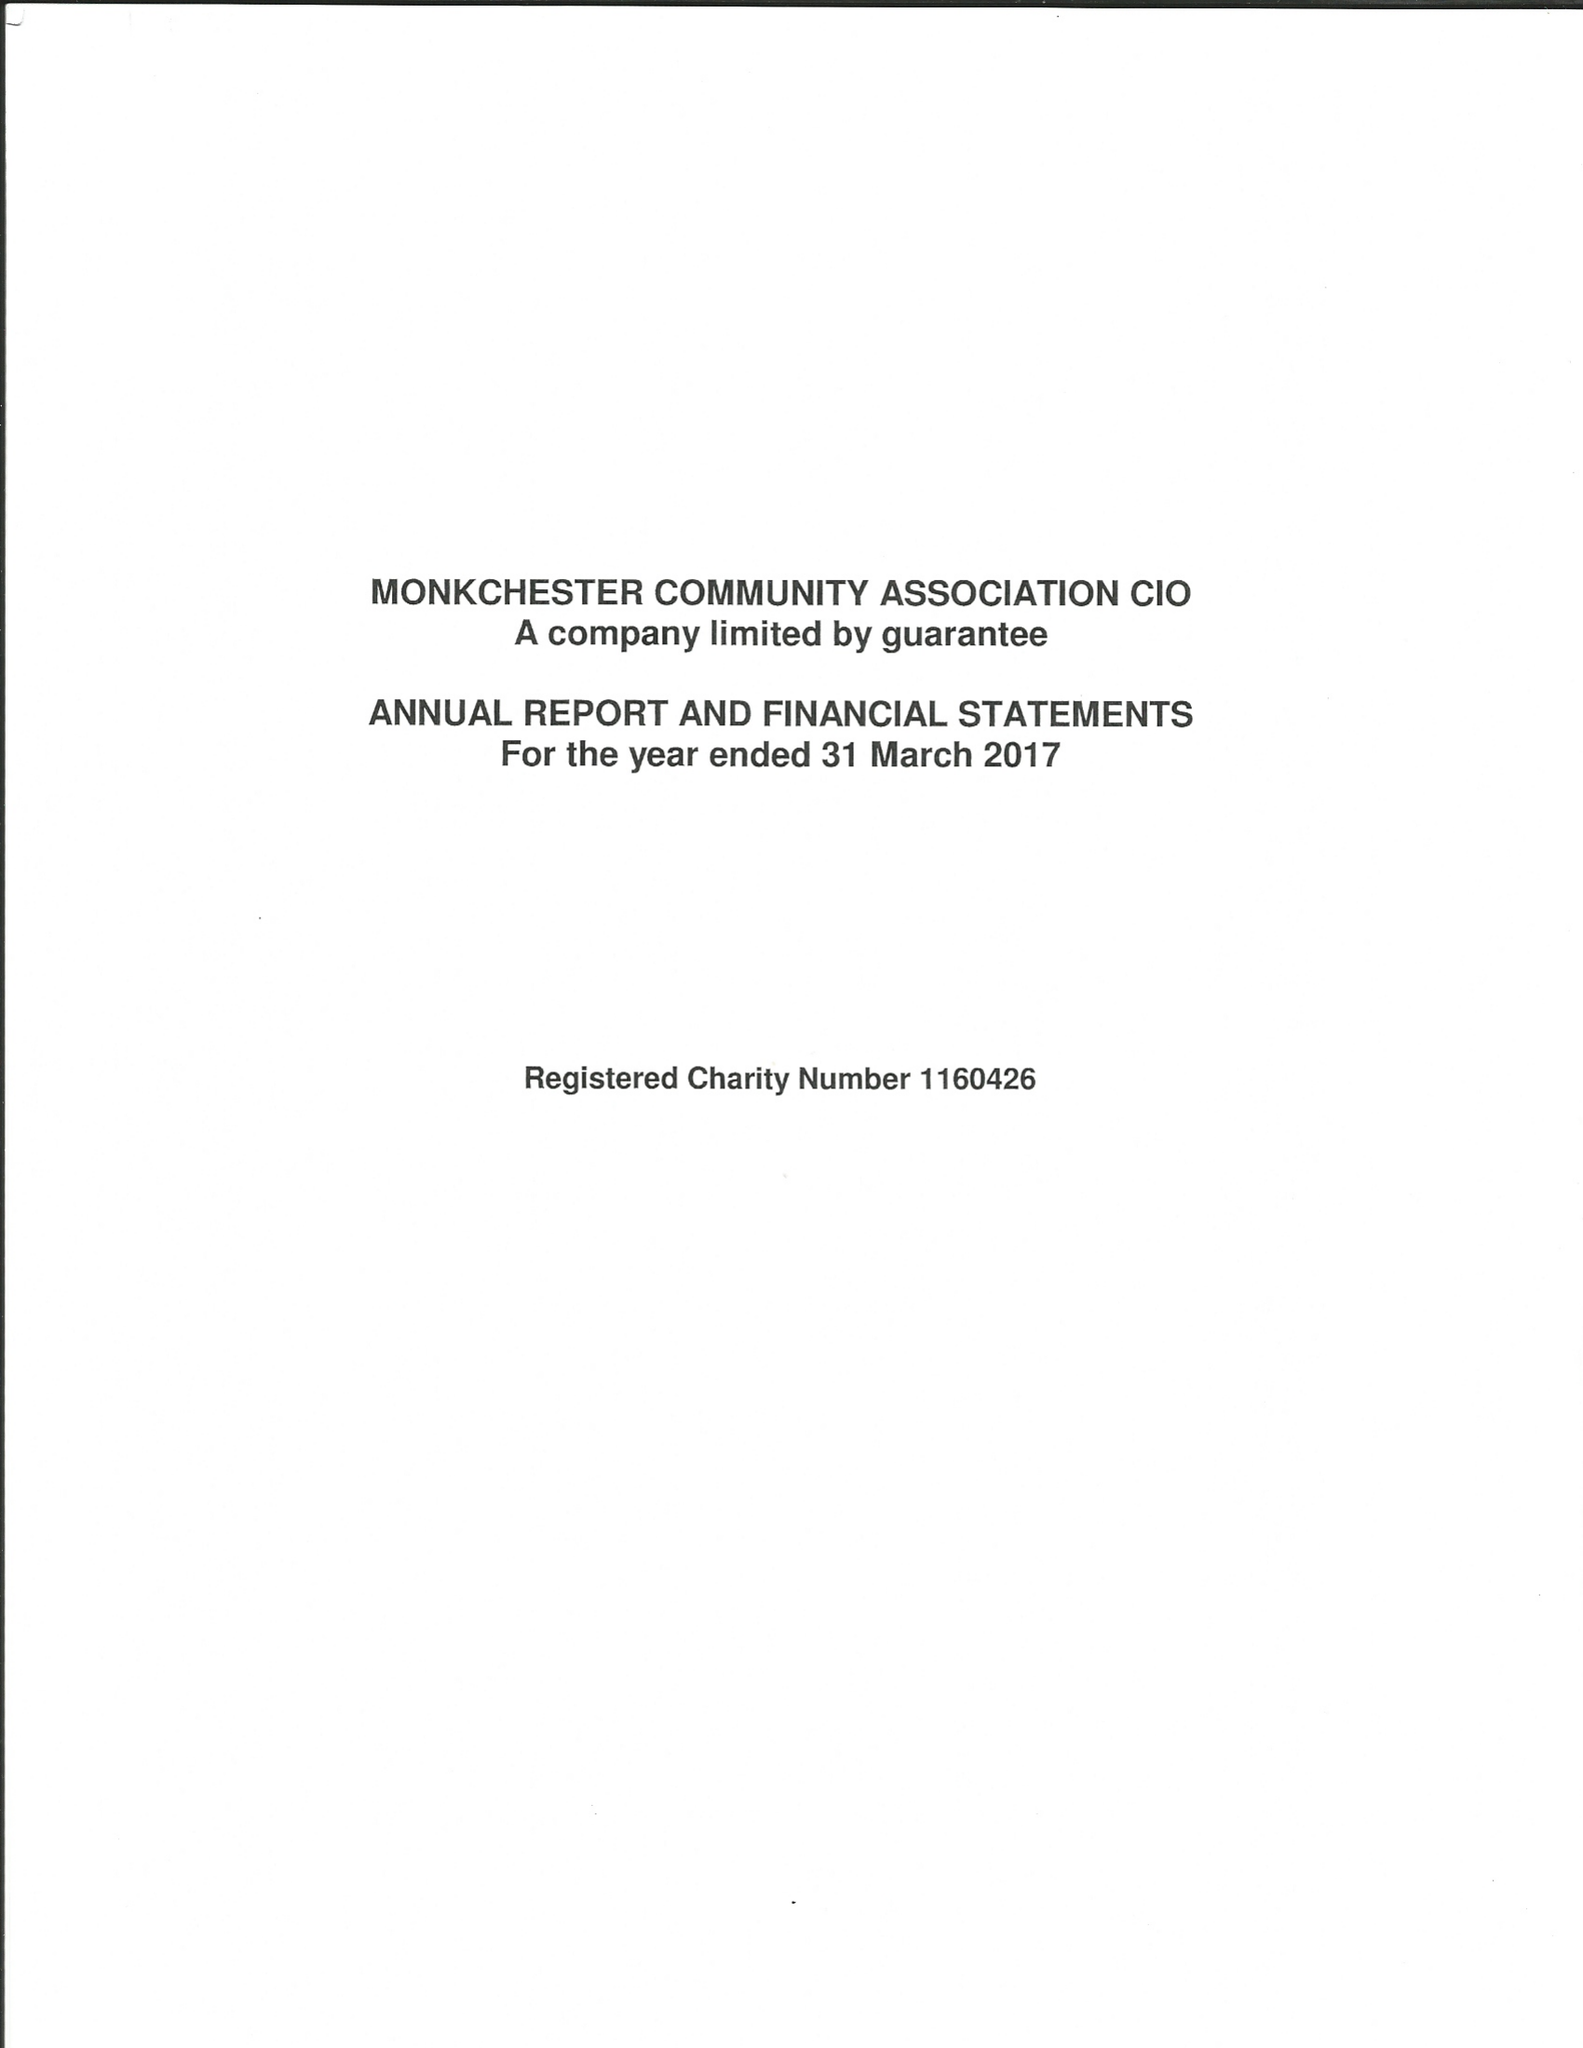What is the value for the address__street_line?
Answer the question using a single word or phrase. 204 MONKCHESTER ROAD 